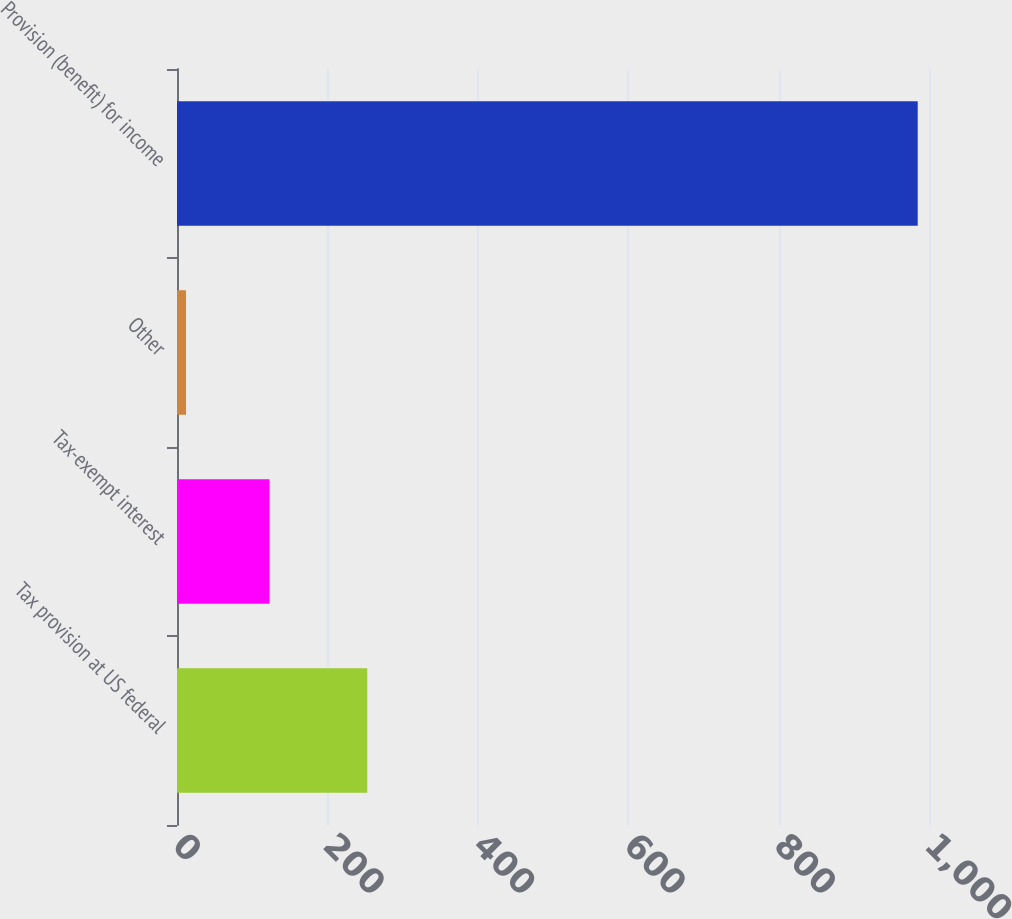<chart> <loc_0><loc_0><loc_500><loc_500><bar_chart><fcel>Tax provision at US federal<fcel>Tax-exempt interest<fcel>Other<fcel>Provision (benefit) for income<nl><fcel>253<fcel>123<fcel>12<fcel>985<nl></chart> 